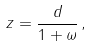Convert formula to latex. <formula><loc_0><loc_0><loc_500><loc_500>z = \frac { d } { 1 + \omega } \, ,</formula> 